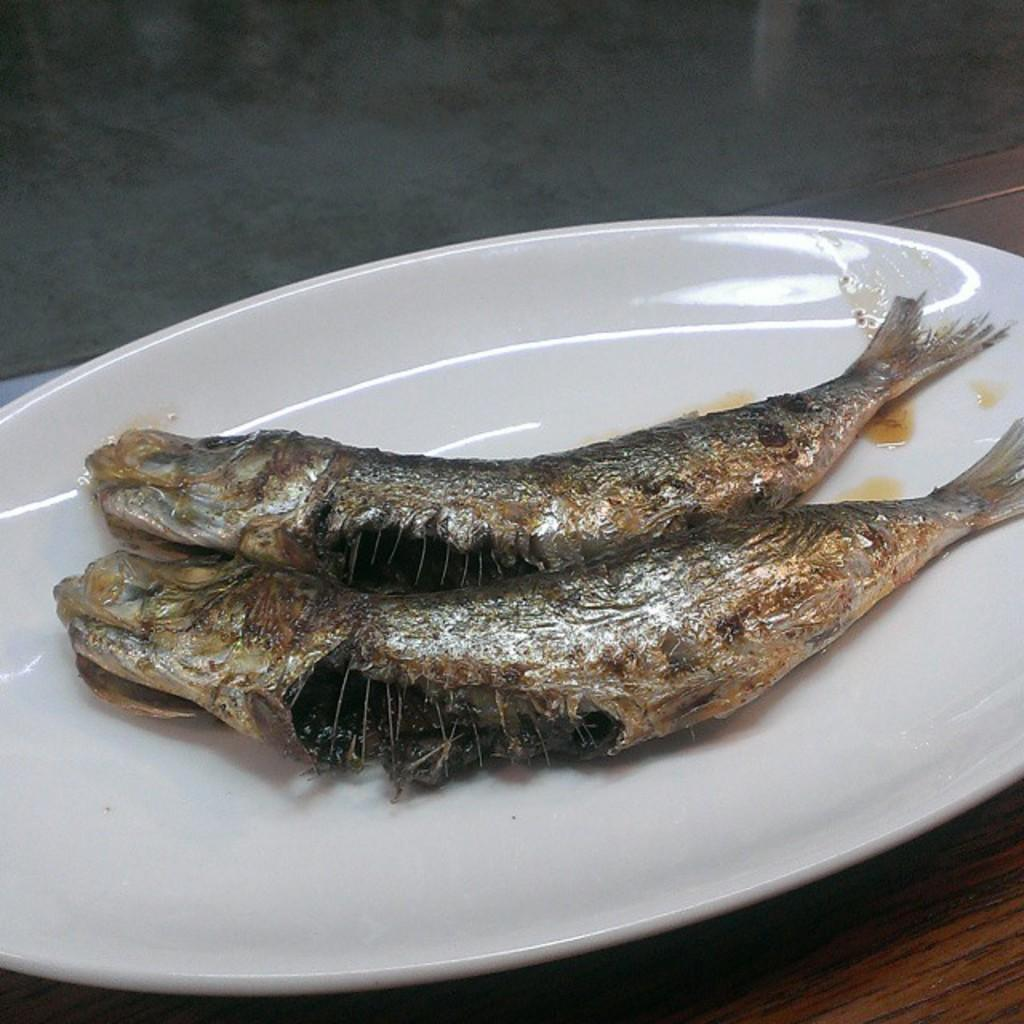What type of food can be seen in the image? There are two cooked fishes in the image. How are the fishes prepared? The fishes are cooked. On what surface are the fishes placed? The fishes are placed on a white color plate. What type of coal is used to cook the fishes in the image? There is no coal mentioned or visible in the image; the fishes are simply described as cooked. 